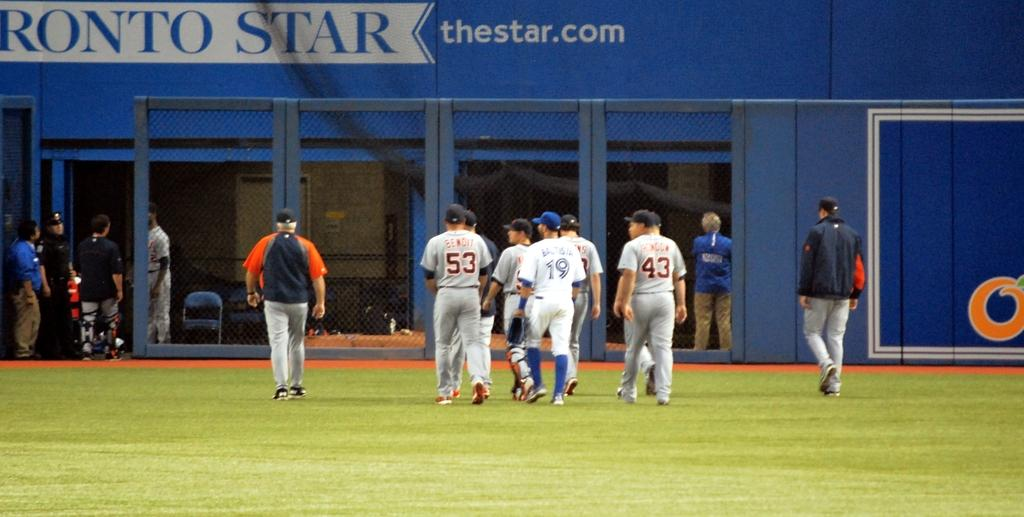<image>
Write a terse but informative summary of the picture. Several players with the numbers 53, 19 and 43 walking across the field 